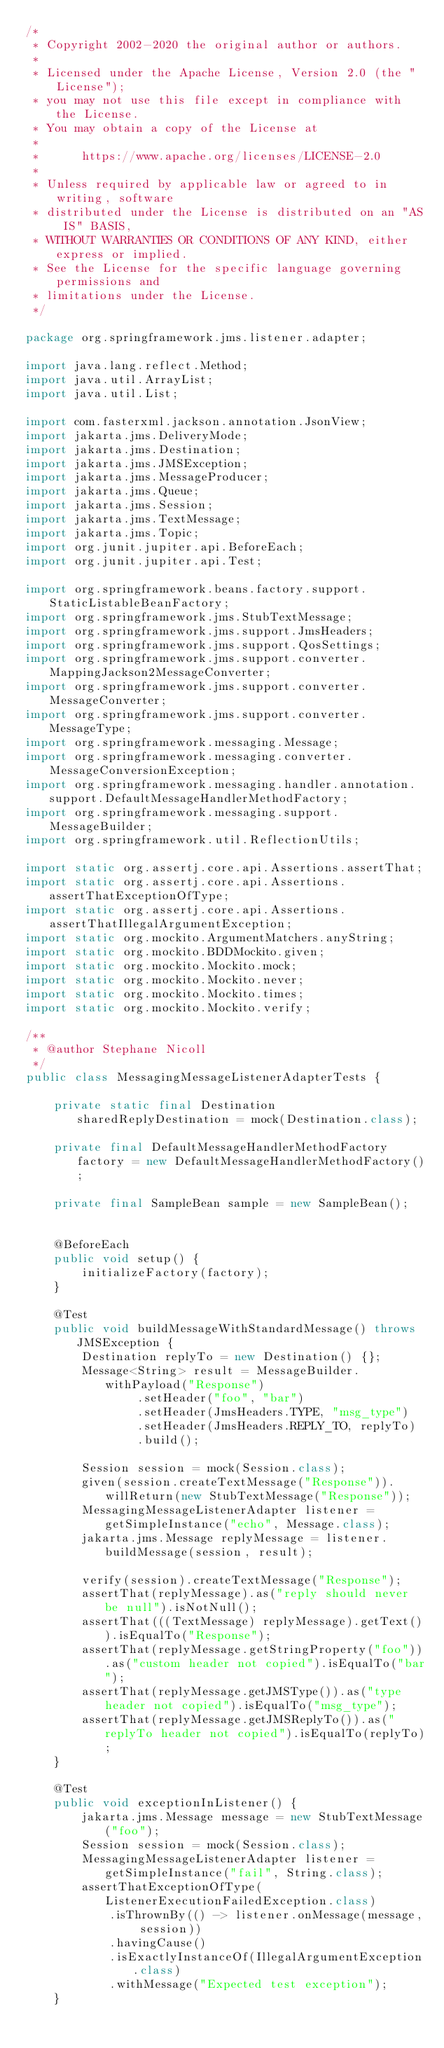Convert code to text. <code><loc_0><loc_0><loc_500><loc_500><_Java_>/*
 * Copyright 2002-2020 the original author or authors.
 *
 * Licensed under the Apache License, Version 2.0 (the "License");
 * you may not use this file except in compliance with the License.
 * You may obtain a copy of the License at
 *
 *      https://www.apache.org/licenses/LICENSE-2.0
 *
 * Unless required by applicable law or agreed to in writing, software
 * distributed under the License is distributed on an "AS IS" BASIS,
 * WITHOUT WARRANTIES OR CONDITIONS OF ANY KIND, either express or implied.
 * See the License for the specific language governing permissions and
 * limitations under the License.
 */

package org.springframework.jms.listener.adapter;

import java.lang.reflect.Method;
import java.util.ArrayList;
import java.util.List;

import com.fasterxml.jackson.annotation.JsonView;
import jakarta.jms.DeliveryMode;
import jakarta.jms.Destination;
import jakarta.jms.JMSException;
import jakarta.jms.MessageProducer;
import jakarta.jms.Queue;
import jakarta.jms.Session;
import jakarta.jms.TextMessage;
import jakarta.jms.Topic;
import org.junit.jupiter.api.BeforeEach;
import org.junit.jupiter.api.Test;

import org.springframework.beans.factory.support.StaticListableBeanFactory;
import org.springframework.jms.StubTextMessage;
import org.springframework.jms.support.JmsHeaders;
import org.springframework.jms.support.QosSettings;
import org.springframework.jms.support.converter.MappingJackson2MessageConverter;
import org.springframework.jms.support.converter.MessageConverter;
import org.springframework.jms.support.converter.MessageType;
import org.springframework.messaging.Message;
import org.springframework.messaging.converter.MessageConversionException;
import org.springframework.messaging.handler.annotation.support.DefaultMessageHandlerMethodFactory;
import org.springframework.messaging.support.MessageBuilder;
import org.springframework.util.ReflectionUtils;

import static org.assertj.core.api.Assertions.assertThat;
import static org.assertj.core.api.Assertions.assertThatExceptionOfType;
import static org.assertj.core.api.Assertions.assertThatIllegalArgumentException;
import static org.mockito.ArgumentMatchers.anyString;
import static org.mockito.BDDMockito.given;
import static org.mockito.Mockito.mock;
import static org.mockito.Mockito.never;
import static org.mockito.Mockito.times;
import static org.mockito.Mockito.verify;

/**
 * @author Stephane Nicoll
 */
public class MessagingMessageListenerAdapterTests {

	private static final Destination sharedReplyDestination = mock(Destination.class);

	private final DefaultMessageHandlerMethodFactory factory = new DefaultMessageHandlerMethodFactory();

	private final SampleBean sample = new SampleBean();


	@BeforeEach
	public void setup() {
		initializeFactory(factory);
	}

	@Test
	public void buildMessageWithStandardMessage() throws JMSException {
		Destination replyTo = new Destination() {};
		Message<String> result = MessageBuilder.withPayload("Response")
				.setHeader("foo", "bar")
				.setHeader(JmsHeaders.TYPE, "msg_type")
				.setHeader(JmsHeaders.REPLY_TO, replyTo)
				.build();

		Session session = mock(Session.class);
		given(session.createTextMessage("Response")).willReturn(new StubTextMessage("Response"));
		MessagingMessageListenerAdapter listener = getSimpleInstance("echo", Message.class);
		jakarta.jms.Message replyMessage = listener.buildMessage(session, result);

		verify(session).createTextMessage("Response");
		assertThat(replyMessage).as("reply should never be null").isNotNull();
		assertThat(((TextMessage) replyMessage).getText()).isEqualTo("Response");
		assertThat(replyMessage.getStringProperty("foo")).as("custom header not copied").isEqualTo("bar");
		assertThat(replyMessage.getJMSType()).as("type header not copied").isEqualTo("msg_type");
		assertThat(replyMessage.getJMSReplyTo()).as("replyTo header not copied").isEqualTo(replyTo);
	}

	@Test
	public void exceptionInListener() {
		jakarta.jms.Message message = new StubTextMessage("foo");
		Session session = mock(Session.class);
		MessagingMessageListenerAdapter listener = getSimpleInstance("fail", String.class);
		assertThatExceptionOfType(ListenerExecutionFailedException.class)
			.isThrownBy(() -> listener.onMessage(message, session))
			.havingCause()
			.isExactlyInstanceOf(IllegalArgumentException.class)
			.withMessage("Expected test exception");
	}
</code> 